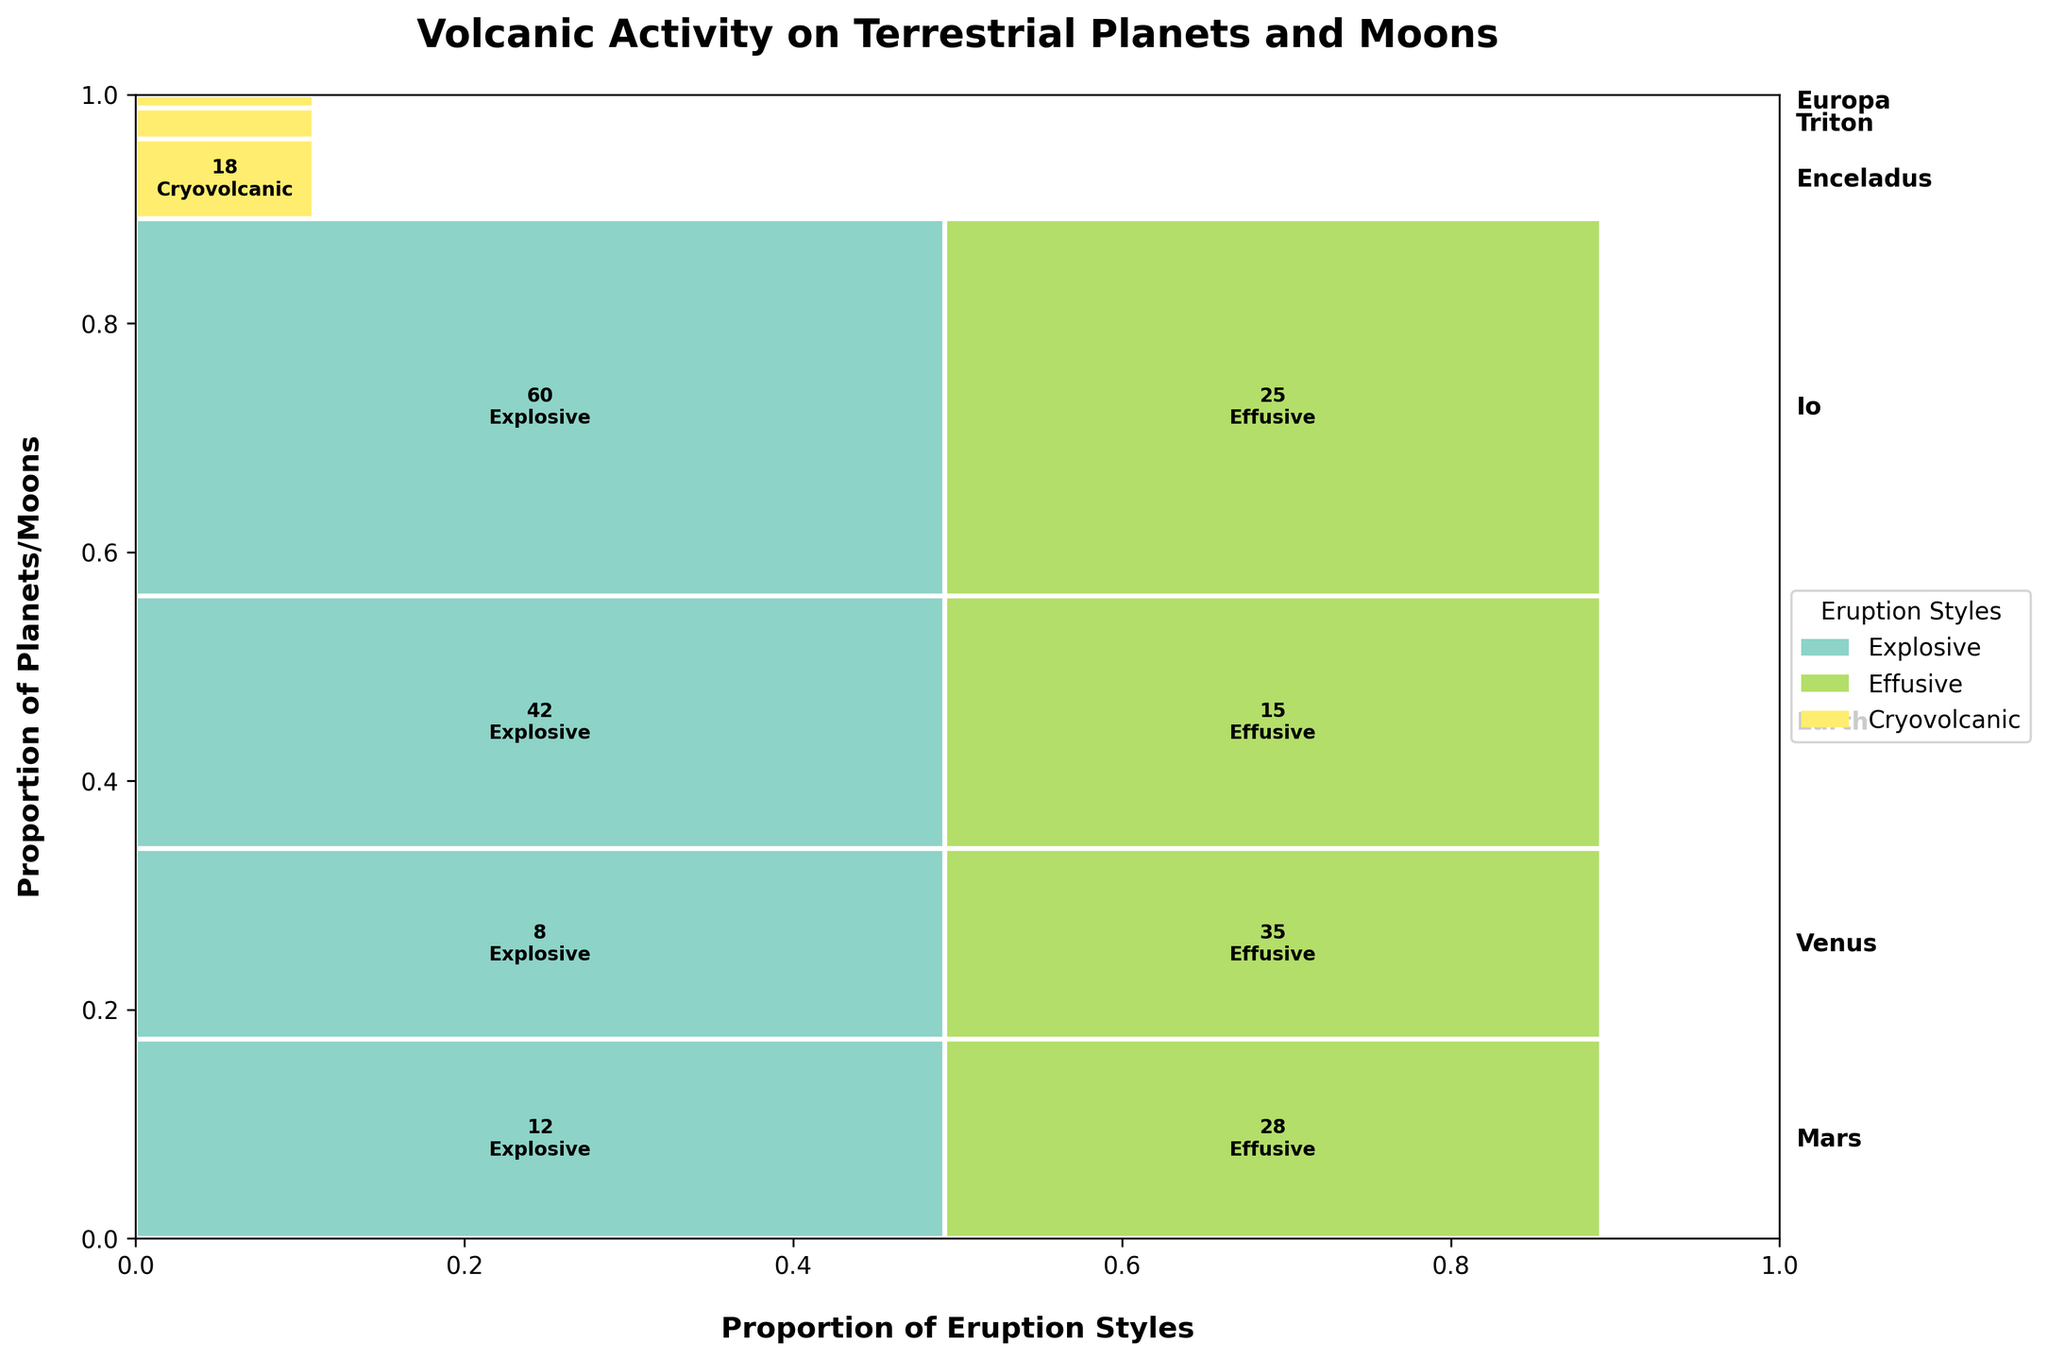What is the total number of explosive eruptions recorded on Mars? To find the total number of explosive eruptions on Mars, sum the counts of all explosive eruptions across different geological periods on Mars. The counts are 12 (Noachian) + 5 (Amazonian) = 17.
Answer: 17 Which planet or moon has the highest number of effusive eruptions? By observing the mosaic plot, identify which planet or moon has the largest rectangle representing effusive eruptions. Venus has 35 effusive eruptions, which is the highest.
Answer: Venus How does the cryovolcanic activity on Enceladus compare to cryovolcanic activity on Triton? Compare the size of the rectangles representing cryovolcanic activity on Enceladus and Triton. Enceladus has 18 eruptions, whereas Triton has 7, indicating more cryovolcanic activity on Enceladus.
Answer: Enceladus has more What is the total number of volcanic eruptions on Earth across all periods? Sum the counts for both explosive and effusive eruptions on Earth: 42 (explosive, Cenozoic) + 15 (effusive, Mesozoic) = 57.
Answer: 57 What proportion of Io's volcanic activity is explosive? Calculate the proportion by dividing Io's explosive eruptions by the total volcanic activity on Io: 60 (explosive) / (60 + 25) = 60 / 85 ≈ 0.706 or 70.6%.
Answer: 70.6% Which planet/moon has the smallest number of volcanic eruptions, and what type are they? Identify the planet/moon with the smallest total count in any eruption style. Europa has the smallest number with 3 cryovolcanic eruptions.
Answer: Europa, cryovolcanic How does the total volcanic activity on Io compare to Mars? Sum the counts of all eruption styles for each: Io (60 + 25 = 85) and Mars (12 + 28 + 5 = 45). Io has more volcanic activity than Mars.
Answer: Io has more What is the primary geological period associated with the effusive eruptions on Mars? Identify the geological period with the largest rectangle associated with effusive eruptions on Mars. Hesperian with 28 effusive eruptions.
Answer: Hesperian Which eruption style is most common across all planets and moons? Sum the counts across all planets and moons for each eruption style and compare. Effusive: 28 (Mars) + 35 (Venus) + 15 (Earth) + 25 (Io) = 103, Explosive: 12 (Mars) + 5 (Mars) + 8 (Venus) + 42 (Earth) + 60 (Io) = 127; Cryovolcanic: 18 (Enceladus) + 7 (Triton) + 3 (Europa) = 28. Explosive eruptions are the most common overall.
Answer: Explosive 